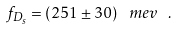Convert formula to latex. <formula><loc_0><loc_0><loc_500><loc_500>f _ { D _ { s } } = \left ( 2 5 1 \pm 3 0 \right ) \ m e v \ .</formula> 